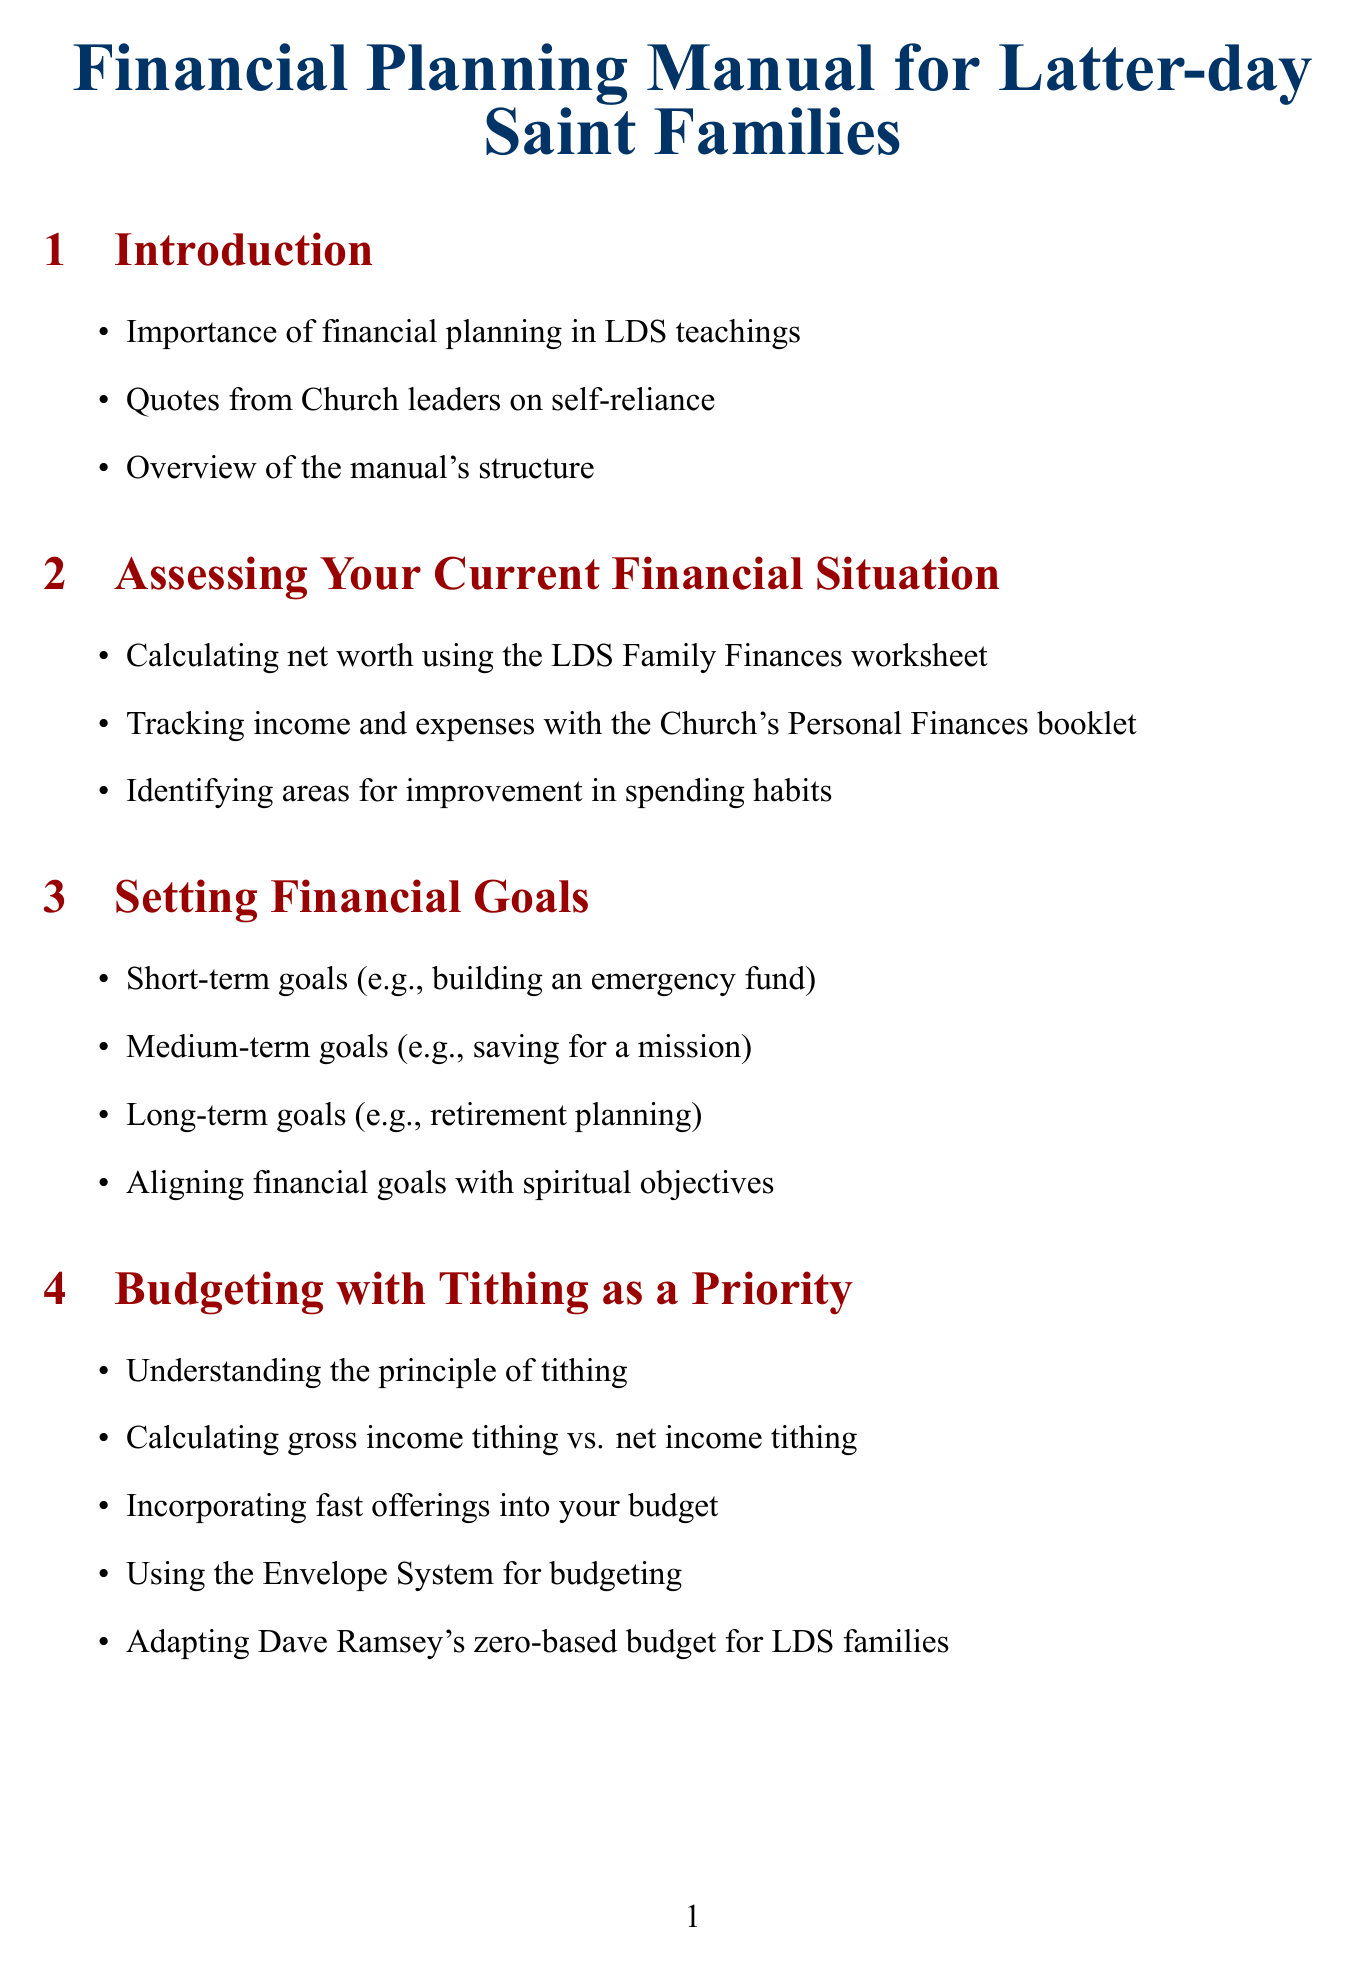What is the title of the manual? The title is provided in the document and is crucial for understanding its focus on financial planning for families.
Answer: Financial Planning Manual for Latter-day Saint Families How many months should an emergency fund cover? The document states the recommended coverage period for an emergency fund.
Answer: 3-6 month What method is suggested for debt management? The document mentions a specific method for managing debt that can be implemented by families.
Answer: Debt snowball method What is one of the short-term financial goals listed? The manual provides examples of financial goals, including a specific short-term goal.
Answer: Building an emergency fund Which fund can be contributed to beyond tithing? The document lists additional charitable contributions that families can consider, one of which is specified here.
Answer: Perpetual Education Fund What is the role of the Church's welfare program? The document addresses how the Church's welfare program relates to financial planning and insurance needs.
Answer: Risk management Name a budgeting system mentioned in the manual. The manual provides examples of budgeting systems that align with the financial guidelines for families.
Answer: Envelope System What is a recommended book for financial education? The document includes suggestions for resources and tools, one of which is a specific book title.
Answer: One for the Money How should families teach children financial responsibility? The document discusses methods for instilling financial responsibility in children.
Answer: 'Save, spend, give' system 